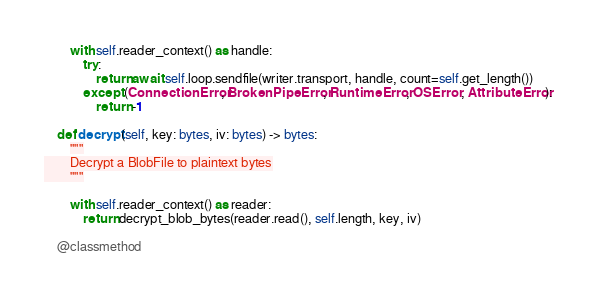Convert code to text. <code><loc_0><loc_0><loc_500><loc_500><_Python_>        with self.reader_context() as handle:
            try:
                return await self.loop.sendfile(writer.transport, handle, count=self.get_length())
            except (ConnectionError, BrokenPipeError, RuntimeError, OSError, AttributeError):
                return -1

    def decrypt(self, key: bytes, iv: bytes) -> bytes:
        """
        Decrypt a BlobFile to plaintext bytes
        """

        with self.reader_context() as reader:
            return decrypt_blob_bytes(reader.read(), self.length, key, iv)

    @classmethod</code> 